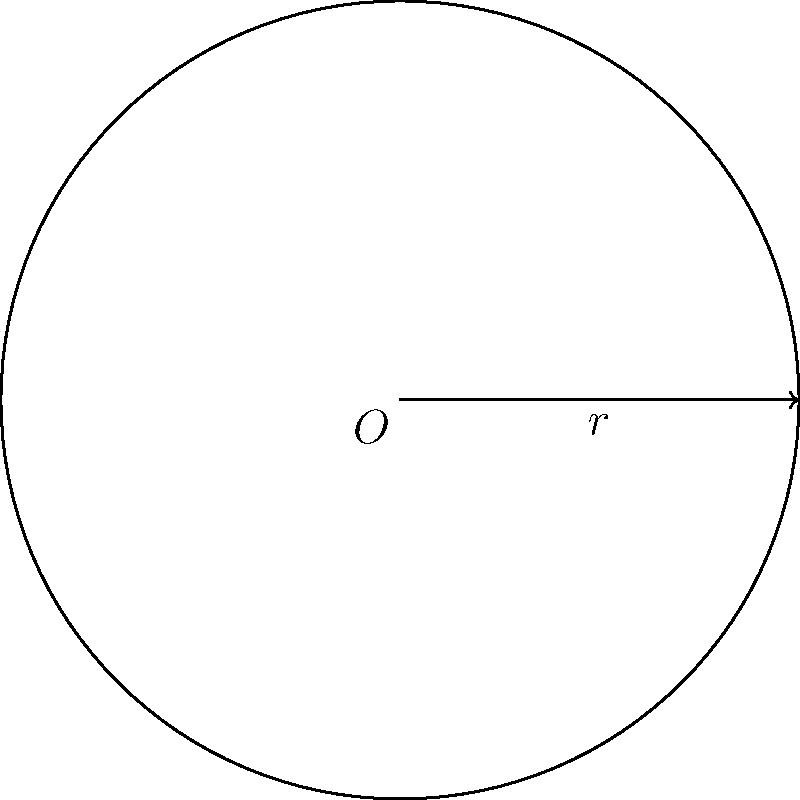In a medical imaging study, a circular tumor is detected with a radius of 2.5 cm. Calculate the circumference of the tumor to determine the extent of surgical excision required. Use $\pi \approx 3.14$ for your calculations. To calculate the circumference of a circle given its radius, we use the formula:

$$C = 2\pi r$$

Where:
$C$ = circumference
$\pi$ = pi (approximately 3.14)
$r$ = radius

Given:
$r = 2.5$ cm
$\pi \approx 3.14$

Step 1: Substitute the values into the formula
$$C = 2 \times 3.14 \times 2.5$$

Step 2: Perform the multiplication
$$C = 6.28 \times 2.5 = 15.7$$

Therefore, the circumference of the tumor is approximately 15.7 cm.
Answer: 15.7 cm 